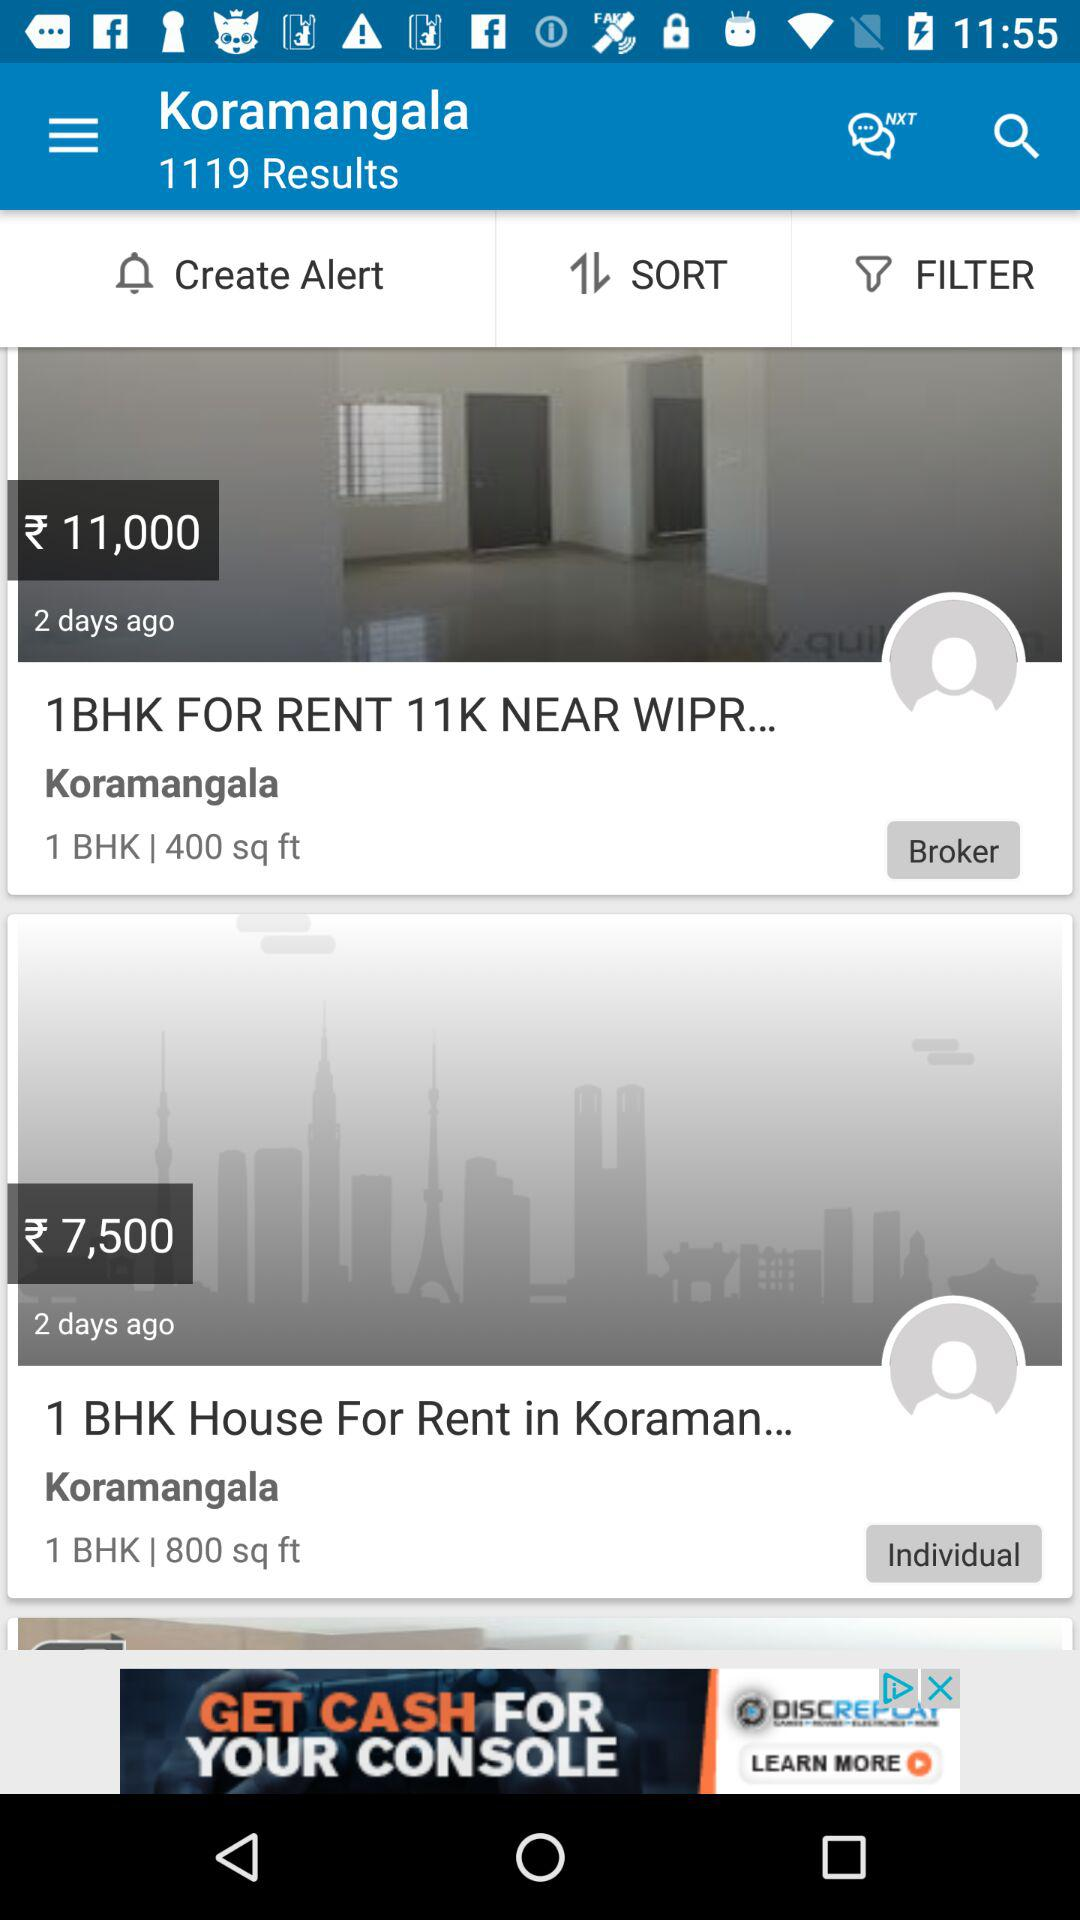What is the location of the flat? The location is Koramangala. 